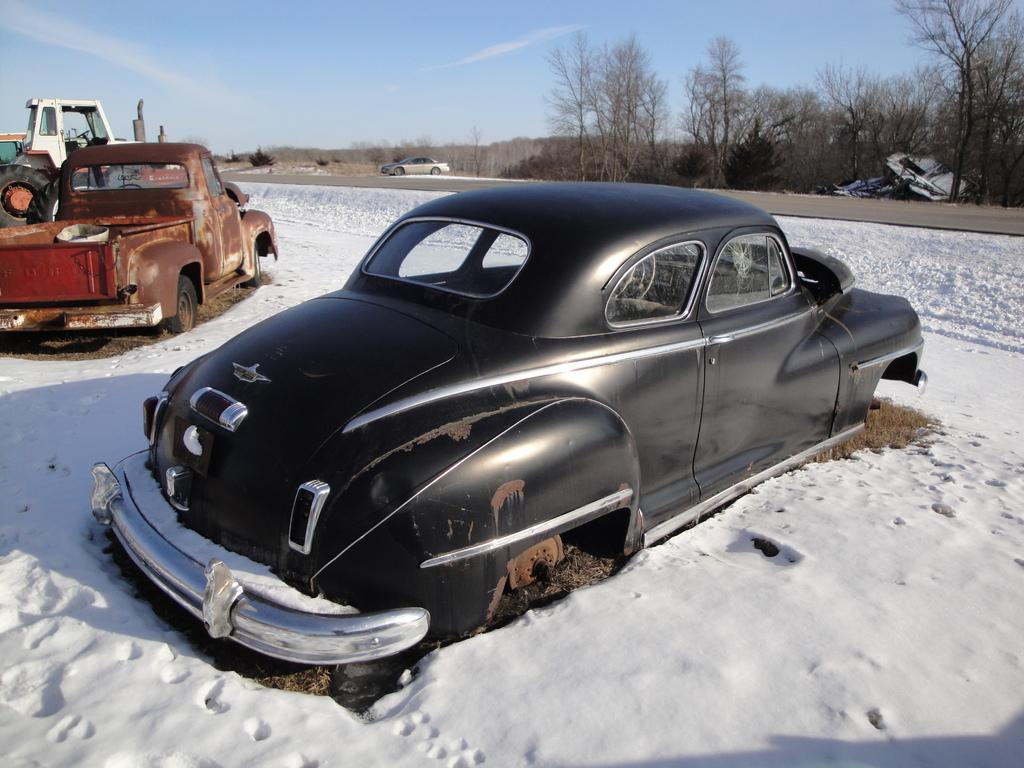What type of vehicle is in the foreground of the image? There is a black color car in the foreground of the image. What is the position of the car in the image? The car is on the ground. What is the surrounding environment like around the car? There is snow around the car. What can be seen in the background of the image? There are vehicles, a road, trees, and the sky visible in the background of the image. What type of crate is being used to store the time in the image? There is no crate or time present in the image; it features a black color car with snow around it and a background with vehicles, a road, trees, and the sky. 